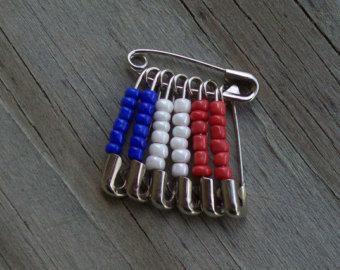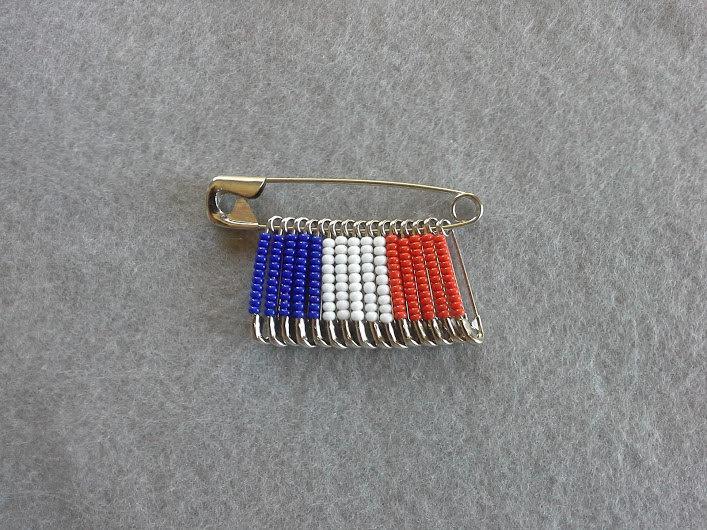The first image is the image on the left, the second image is the image on the right. Assess this claim about the two images: "At least one image shows pins with beads forming an American flag pattern.". Correct or not? Answer yes or no. No. 